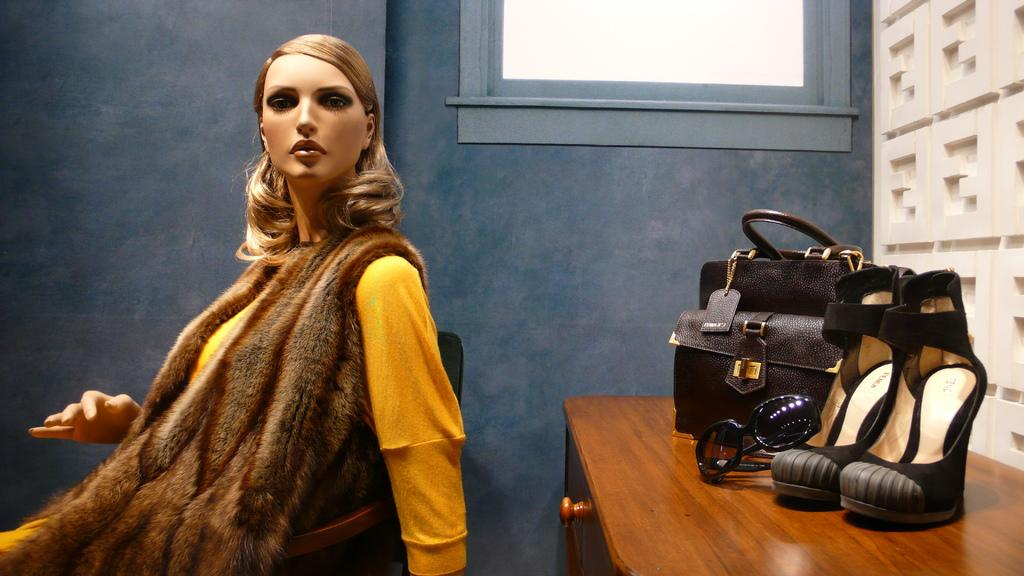What is the woman doing in the image? The woman is seated on a chair in the image. What objects are on the table in the image? There is a bag, shoes, and glasses on the table in the image. What type of pot is being used for breakfast in the image? There is no pot or breakfast present in the image. What ornament is hanging from the ceiling in the image? There is no ornament hanging from the ceiling in the image. 